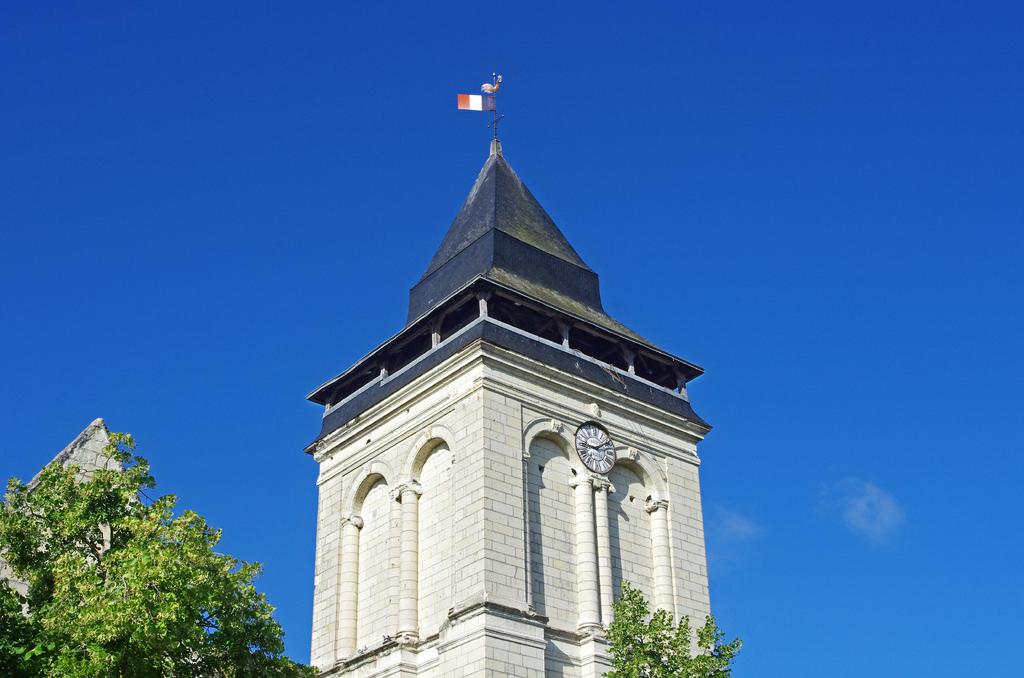What is the main structure in the image? There is a tower in the image. What can be seen on the wall inside the tower? There is a clock on the wall. What is on top of the tower? There is a flag with a pole on top of the tower. What type of vegetation is visible in the image? There are trees visible in the image. What is the color of the sky in the background of the image? The sky is visible in the background of the image, and it is blue in color. How many times does the paper need to be turned to complete a full rotation in the image? There is: There is no paper present in the image, so it is not possible to determine how many times it would need to be turned to complete a full rotation. 